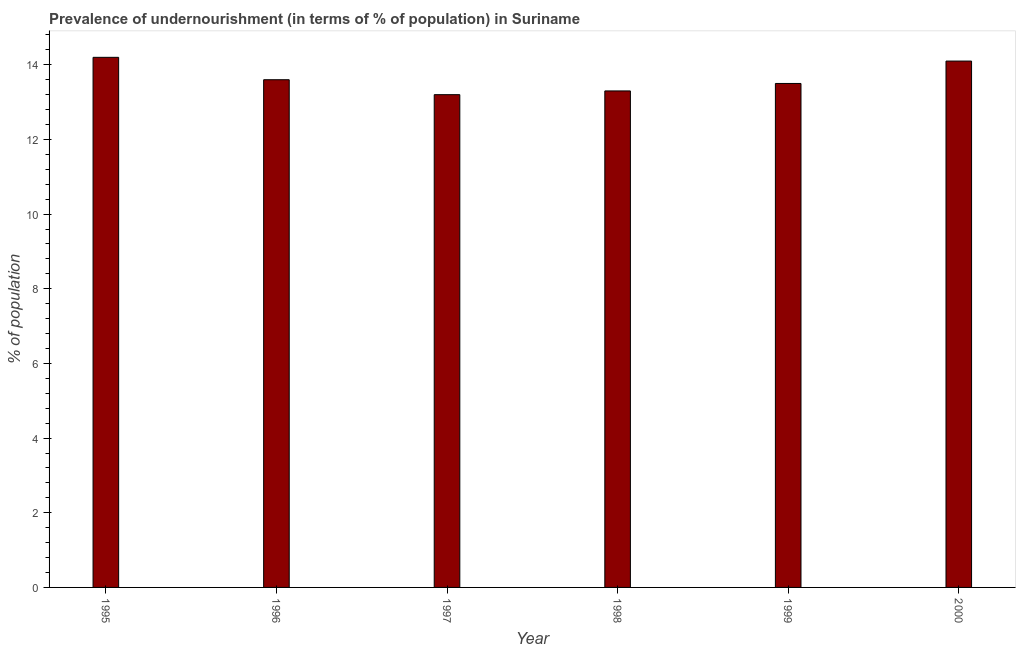Does the graph contain any zero values?
Your response must be concise. No. What is the title of the graph?
Offer a terse response. Prevalence of undernourishment (in terms of % of population) in Suriname. What is the label or title of the Y-axis?
Your answer should be very brief. % of population. Across all years, what is the minimum percentage of undernourished population?
Give a very brief answer. 13.2. In which year was the percentage of undernourished population maximum?
Keep it short and to the point. 1995. What is the sum of the percentage of undernourished population?
Your response must be concise. 81.9. What is the difference between the percentage of undernourished population in 1997 and 1999?
Keep it short and to the point. -0.3. What is the average percentage of undernourished population per year?
Ensure brevity in your answer.  13.65. What is the median percentage of undernourished population?
Provide a short and direct response. 13.55. How many bars are there?
Your answer should be very brief. 6. Are the values on the major ticks of Y-axis written in scientific E-notation?
Provide a succinct answer. No. What is the % of population of 1997?
Your response must be concise. 13.2. What is the % of population in 1999?
Your answer should be compact. 13.5. What is the % of population of 2000?
Your response must be concise. 14.1. What is the difference between the % of population in 1996 and 2000?
Provide a succinct answer. -0.5. What is the difference between the % of population in 1997 and 1998?
Provide a succinct answer. -0.1. What is the difference between the % of population in 1997 and 1999?
Offer a very short reply. -0.3. What is the difference between the % of population in 1997 and 2000?
Ensure brevity in your answer.  -0.9. What is the ratio of the % of population in 1995 to that in 1996?
Keep it short and to the point. 1.04. What is the ratio of the % of population in 1995 to that in 1997?
Make the answer very short. 1.08. What is the ratio of the % of population in 1995 to that in 1998?
Ensure brevity in your answer.  1.07. What is the ratio of the % of population in 1995 to that in 1999?
Offer a terse response. 1.05. What is the ratio of the % of population in 1995 to that in 2000?
Offer a terse response. 1.01. What is the ratio of the % of population in 1996 to that in 1999?
Ensure brevity in your answer.  1.01. What is the ratio of the % of population in 1997 to that in 1998?
Offer a very short reply. 0.99. What is the ratio of the % of population in 1997 to that in 1999?
Your answer should be very brief. 0.98. What is the ratio of the % of population in 1997 to that in 2000?
Provide a succinct answer. 0.94. What is the ratio of the % of population in 1998 to that in 1999?
Provide a short and direct response. 0.98. What is the ratio of the % of population in 1998 to that in 2000?
Provide a succinct answer. 0.94. What is the ratio of the % of population in 1999 to that in 2000?
Provide a short and direct response. 0.96. 